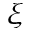<formula> <loc_0><loc_0><loc_500><loc_500>\xi</formula> 